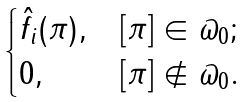<formula> <loc_0><loc_0><loc_500><loc_500>\begin{cases} \hat { f _ { i } } ( \pi ) , & [ \pi ] \in \varpi _ { 0 } ; \\ 0 , & [ \pi ] \notin \varpi _ { 0 } . \end{cases}</formula> 